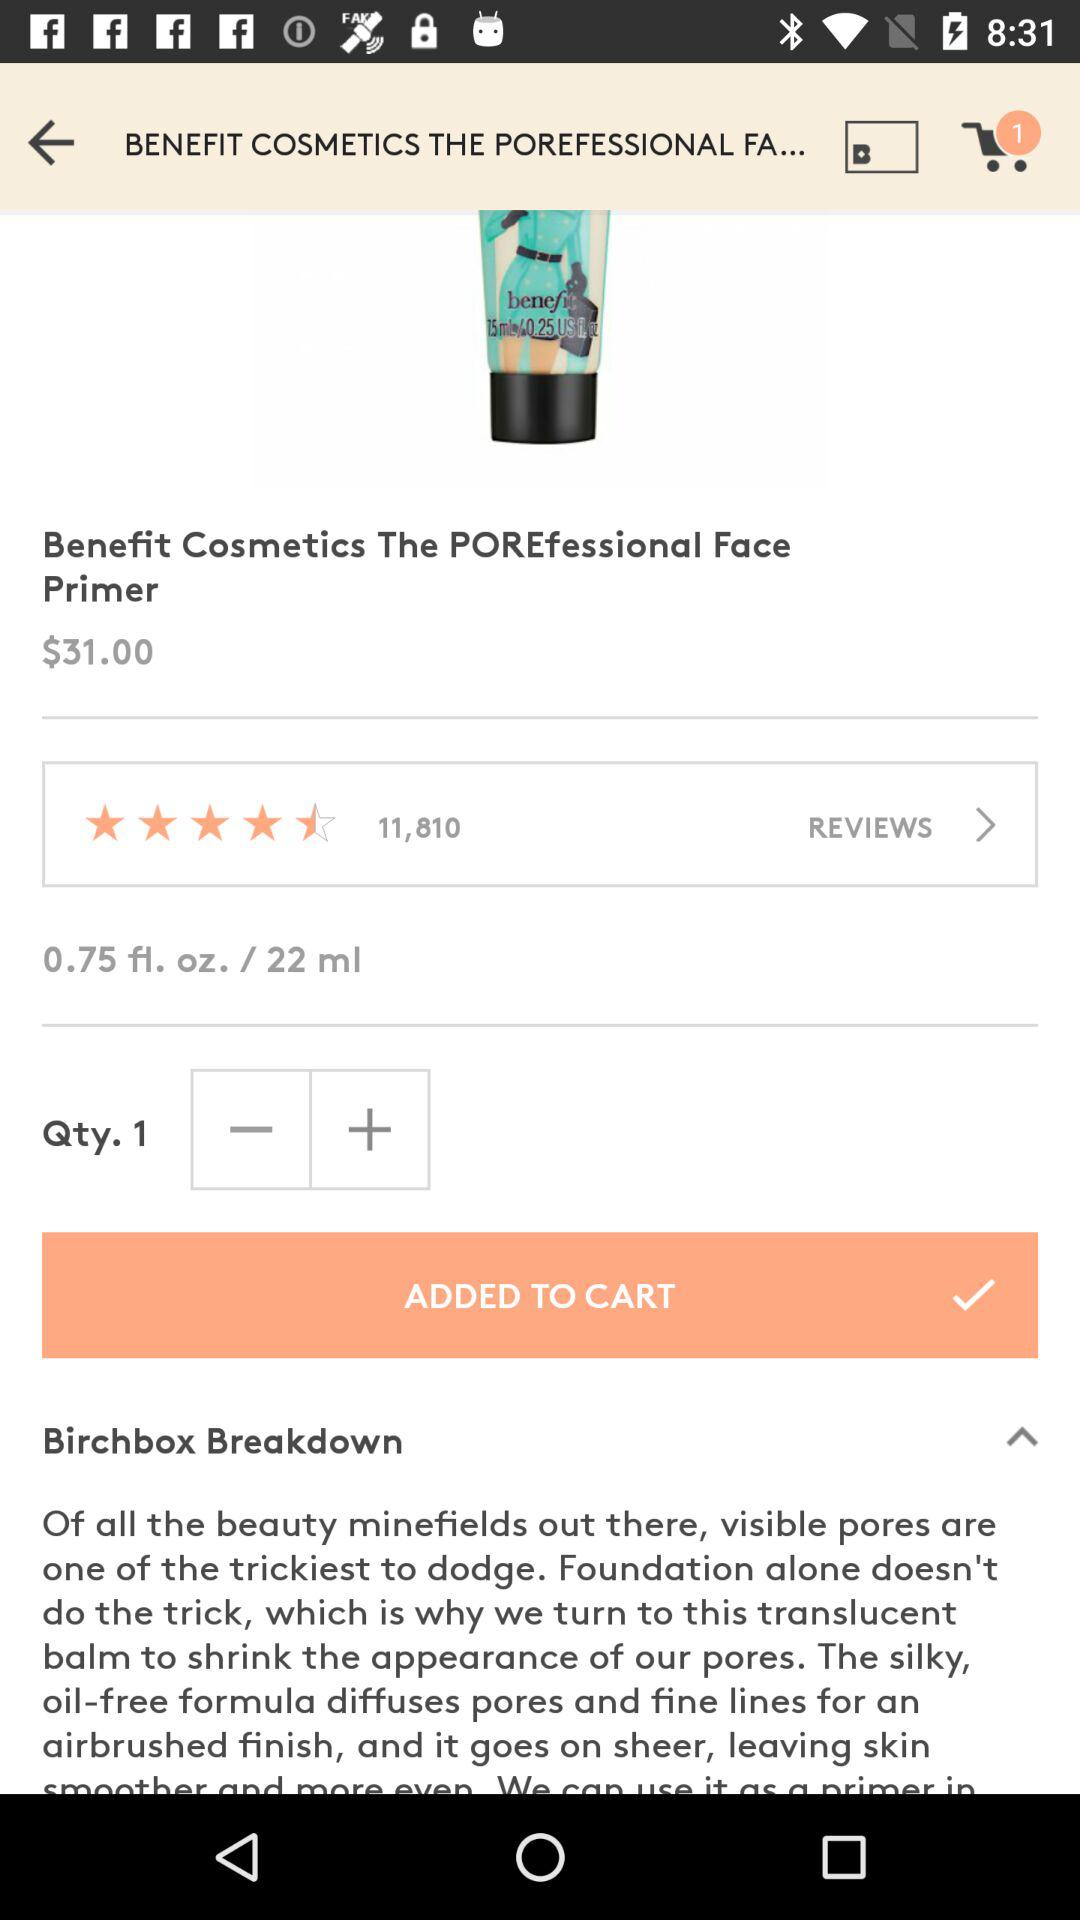What is the quantity of the product? The quantity of the product is 1. 